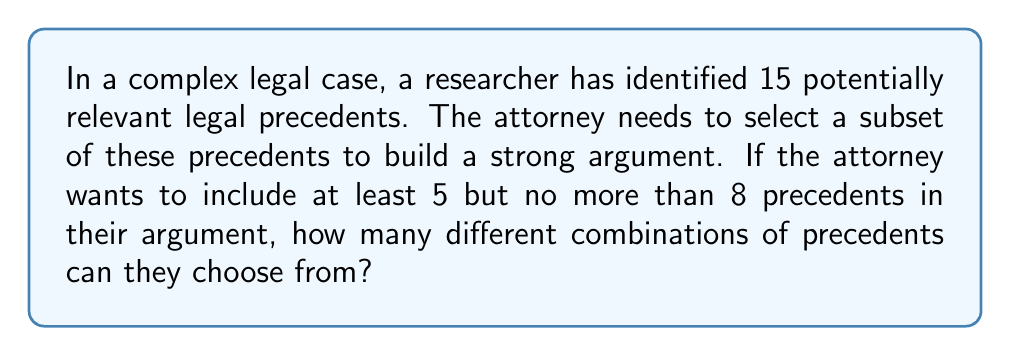Could you help me with this problem? To solve this problem, we need to use the concept of combinations and sum the number of possible combinations for selecting 5, 6, 7, and 8 precedents out of 15.

1. For 5 precedents: $\binom{15}{5}$
2. For 6 precedents: $\binom{15}{6}$
3. For 7 precedents: $\binom{15}{7}$
4. For 8 precedents: $\binom{15}{8}$

The total number of combinations is the sum of these:

$$\binom{15}{5} + \binom{15}{6} + \binom{15}{7} + \binom{15}{8}$$

Let's calculate each combination:

1. $\binom{15}{5} = \frac{15!}{5!(15-5)!} = \frac{15!}{5!10!} = 3003$
2. $\binom{15}{6} = \frac{15!}{6!(15-6)!} = \frac{15!}{6!9!} = 5005$
3. $\binom{15}{7} = \frac{15!}{7!(15-7)!} = \frac{15!}{7!8!} = 6435$
4. $\binom{15}{8} = \frac{15!}{8!(15-8)!} = \frac{15!}{8!7!} = 6435$

Now, we sum these values:

$$3003 + 5005 + 6435 + 6435 = 20878$$

Therefore, the total number of different combinations of precedents the attorney can choose from is 20,878.
Answer: 20,878 